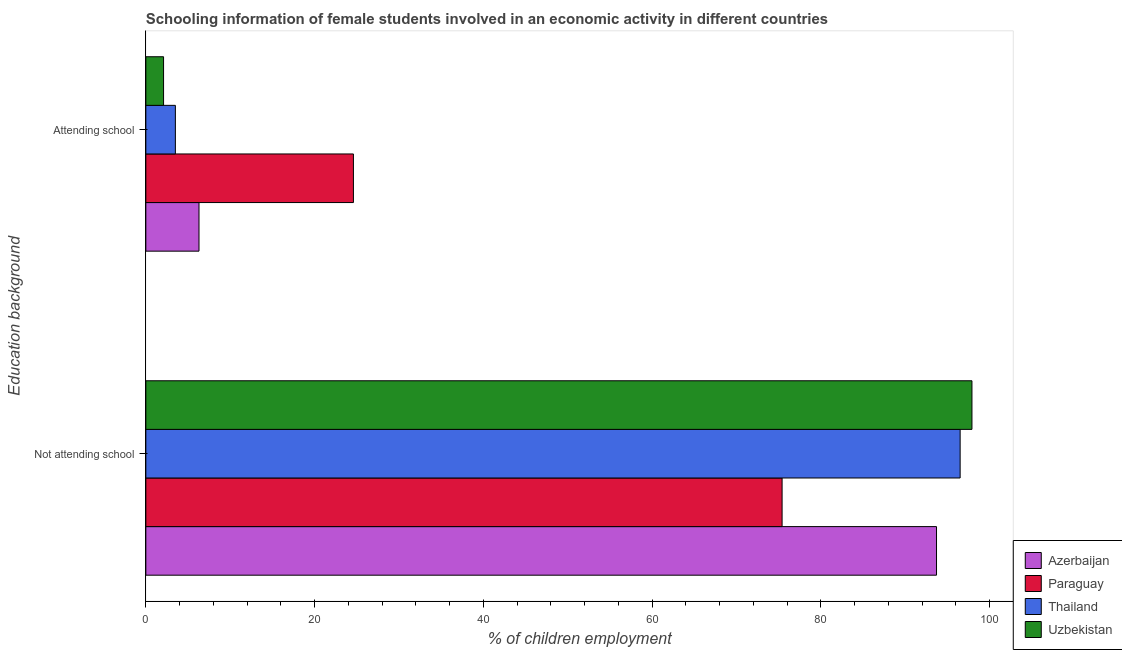How many groups of bars are there?
Your answer should be compact. 2. Are the number of bars per tick equal to the number of legend labels?
Your answer should be very brief. Yes. How many bars are there on the 1st tick from the bottom?
Give a very brief answer. 4. What is the label of the 2nd group of bars from the top?
Make the answer very short. Not attending school. Across all countries, what is the maximum percentage of employed females who are attending school?
Your answer should be very brief. 24.6. Across all countries, what is the minimum percentage of employed females who are not attending school?
Offer a very short reply. 75.4. In which country was the percentage of employed females who are not attending school maximum?
Provide a succinct answer. Uzbekistan. In which country was the percentage of employed females who are not attending school minimum?
Give a very brief answer. Paraguay. What is the total percentage of employed females who are not attending school in the graph?
Provide a short and direct response. 363.5. What is the difference between the percentage of employed females who are attending school in Uzbekistan and that in Azerbaijan?
Provide a short and direct response. -4.2. What is the difference between the percentage of employed females who are attending school in Paraguay and the percentage of employed females who are not attending school in Uzbekistan?
Provide a short and direct response. -73.3. What is the average percentage of employed females who are not attending school per country?
Provide a short and direct response. 90.88. What is the difference between the percentage of employed females who are not attending school and percentage of employed females who are attending school in Uzbekistan?
Keep it short and to the point. 95.8. What is the ratio of the percentage of employed females who are not attending school in Paraguay to that in Azerbaijan?
Make the answer very short. 0.8. Is the percentage of employed females who are not attending school in Uzbekistan less than that in Thailand?
Keep it short and to the point. No. What does the 2nd bar from the top in Not attending school represents?
Your answer should be very brief. Thailand. What does the 4th bar from the bottom in Not attending school represents?
Provide a short and direct response. Uzbekistan. How many bars are there?
Offer a terse response. 8. Are all the bars in the graph horizontal?
Offer a very short reply. Yes. How many countries are there in the graph?
Provide a succinct answer. 4. What is the difference between two consecutive major ticks on the X-axis?
Ensure brevity in your answer.  20. Are the values on the major ticks of X-axis written in scientific E-notation?
Give a very brief answer. No. Does the graph contain grids?
Your response must be concise. No. Where does the legend appear in the graph?
Your answer should be compact. Bottom right. How many legend labels are there?
Give a very brief answer. 4. What is the title of the graph?
Your answer should be compact. Schooling information of female students involved in an economic activity in different countries. Does "Tonga" appear as one of the legend labels in the graph?
Your answer should be very brief. No. What is the label or title of the X-axis?
Provide a succinct answer. % of children employment. What is the label or title of the Y-axis?
Make the answer very short. Education background. What is the % of children employment of Azerbaijan in Not attending school?
Offer a terse response. 93.7. What is the % of children employment of Paraguay in Not attending school?
Offer a terse response. 75.4. What is the % of children employment of Thailand in Not attending school?
Your answer should be compact. 96.5. What is the % of children employment of Uzbekistan in Not attending school?
Your response must be concise. 97.9. What is the % of children employment of Azerbaijan in Attending school?
Your answer should be very brief. 6.3. What is the % of children employment in Paraguay in Attending school?
Offer a very short reply. 24.6. What is the % of children employment in Thailand in Attending school?
Keep it short and to the point. 3.5. Across all Education background, what is the maximum % of children employment of Azerbaijan?
Your answer should be very brief. 93.7. Across all Education background, what is the maximum % of children employment of Paraguay?
Your response must be concise. 75.4. Across all Education background, what is the maximum % of children employment in Thailand?
Your answer should be very brief. 96.5. Across all Education background, what is the maximum % of children employment in Uzbekistan?
Provide a short and direct response. 97.9. Across all Education background, what is the minimum % of children employment in Azerbaijan?
Make the answer very short. 6.3. Across all Education background, what is the minimum % of children employment in Paraguay?
Your answer should be very brief. 24.6. Across all Education background, what is the minimum % of children employment in Thailand?
Offer a very short reply. 3.5. What is the total % of children employment in Azerbaijan in the graph?
Your response must be concise. 100. What is the total % of children employment of Uzbekistan in the graph?
Your response must be concise. 100. What is the difference between the % of children employment of Azerbaijan in Not attending school and that in Attending school?
Provide a succinct answer. 87.4. What is the difference between the % of children employment in Paraguay in Not attending school and that in Attending school?
Give a very brief answer. 50.8. What is the difference between the % of children employment in Thailand in Not attending school and that in Attending school?
Provide a short and direct response. 93. What is the difference between the % of children employment in Uzbekistan in Not attending school and that in Attending school?
Your response must be concise. 95.8. What is the difference between the % of children employment of Azerbaijan in Not attending school and the % of children employment of Paraguay in Attending school?
Offer a terse response. 69.1. What is the difference between the % of children employment in Azerbaijan in Not attending school and the % of children employment in Thailand in Attending school?
Ensure brevity in your answer.  90.2. What is the difference between the % of children employment in Azerbaijan in Not attending school and the % of children employment in Uzbekistan in Attending school?
Offer a very short reply. 91.6. What is the difference between the % of children employment of Paraguay in Not attending school and the % of children employment of Thailand in Attending school?
Give a very brief answer. 71.9. What is the difference between the % of children employment in Paraguay in Not attending school and the % of children employment in Uzbekistan in Attending school?
Offer a terse response. 73.3. What is the difference between the % of children employment of Thailand in Not attending school and the % of children employment of Uzbekistan in Attending school?
Provide a succinct answer. 94.4. What is the average % of children employment of Azerbaijan per Education background?
Provide a short and direct response. 50. What is the average % of children employment in Paraguay per Education background?
Offer a very short reply. 50. What is the average % of children employment in Uzbekistan per Education background?
Provide a succinct answer. 50. What is the difference between the % of children employment of Azerbaijan and % of children employment of Paraguay in Not attending school?
Provide a short and direct response. 18.3. What is the difference between the % of children employment of Paraguay and % of children employment of Thailand in Not attending school?
Keep it short and to the point. -21.1. What is the difference between the % of children employment in Paraguay and % of children employment in Uzbekistan in Not attending school?
Offer a very short reply. -22.5. What is the difference between the % of children employment of Azerbaijan and % of children employment of Paraguay in Attending school?
Your answer should be compact. -18.3. What is the difference between the % of children employment of Azerbaijan and % of children employment of Thailand in Attending school?
Give a very brief answer. 2.8. What is the difference between the % of children employment in Paraguay and % of children employment in Thailand in Attending school?
Provide a succinct answer. 21.1. What is the difference between the % of children employment of Paraguay and % of children employment of Uzbekistan in Attending school?
Offer a terse response. 22.5. What is the difference between the % of children employment in Thailand and % of children employment in Uzbekistan in Attending school?
Ensure brevity in your answer.  1.4. What is the ratio of the % of children employment in Azerbaijan in Not attending school to that in Attending school?
Offer a terse response. 14.87. What is the ratio of the % of children employment in Paraguay in Not attending school to that in Attending school?
Your answer should be very brief. 3.06. What is the ratio of the % of children employment in Thailand in Not attending school to that in Attending school?
Offer a very short reply. 27.57. What is the ratio of the % of children employment of Uzbekistan in Not attending school to that in Attending school?
Your response must be concise. 46.62. What is the difference between the highest and the second highest % of children employment of Azerbaijan?
Provide a succinct answer. 87.4. What is the difference between the highest and the second highest % of children employment in Paraguay?
Provide a short and direct response. 50.8. What is the difference between the highest and the second highest % of children employment of Thailand?
Ensure brevity in your answer.  93. What is the difference between the highest and the second highest % of children employment in Uzbekistan?
Provide a short and direct response. 95.8. What is the difference between the highest and the lowest % of children employment of Azerbaijan?
Offer a very short reply. 87.4. What is the difference between the highest and the lowest % of children employment of Paraguay?
Make the answer very short. 50.8. What is the difference between the highest and the lowest % of children employment of Thailand?
Ensure brevity in your answer.  93. What is the difference between the highest and the lowest % of children employment in Uzbekistan?
Your answer should be compact. 95.8. 